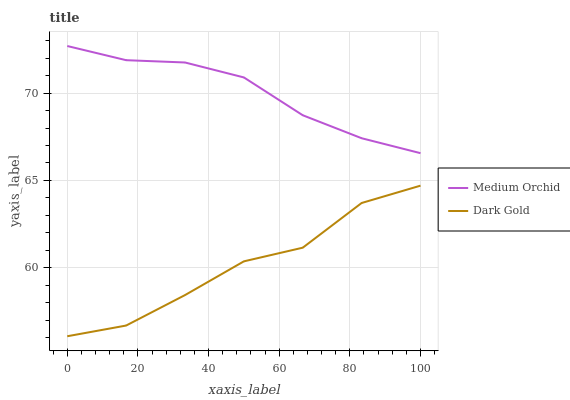Does Dark Gold have the minimum area under the curve?
Answer yes or no. Yes. Does Medium Orchid have the maximum area under the curve?
Answer yes or no. Yes. Does Dark Gold have the maximum area under the curve?
Answer yes or no. No. Is Medium Orchid the smoothest?
Answer yes or no. Yes. Is Dark Gold the roughest?
Answer yes or no. Yes. Is Dark Gold the smoothest?
Answer yes or no. No. Does Dark Gold have the lowest value?
Answer yes or no. Yes. Does Medium Orchid have the highest value?
Answer yes or no. Yes. Does Dark Gold have the highest value?
Answer yes or no. No. Is Dark Gold less than Medium Orchid?
Answer yes or no. Yes. Is Medium Orchid greater than Dark Gold?
Answer yes or no. Yes. Does Dark Gold intersect Medium Orchid?
Answer yes or no. No. 